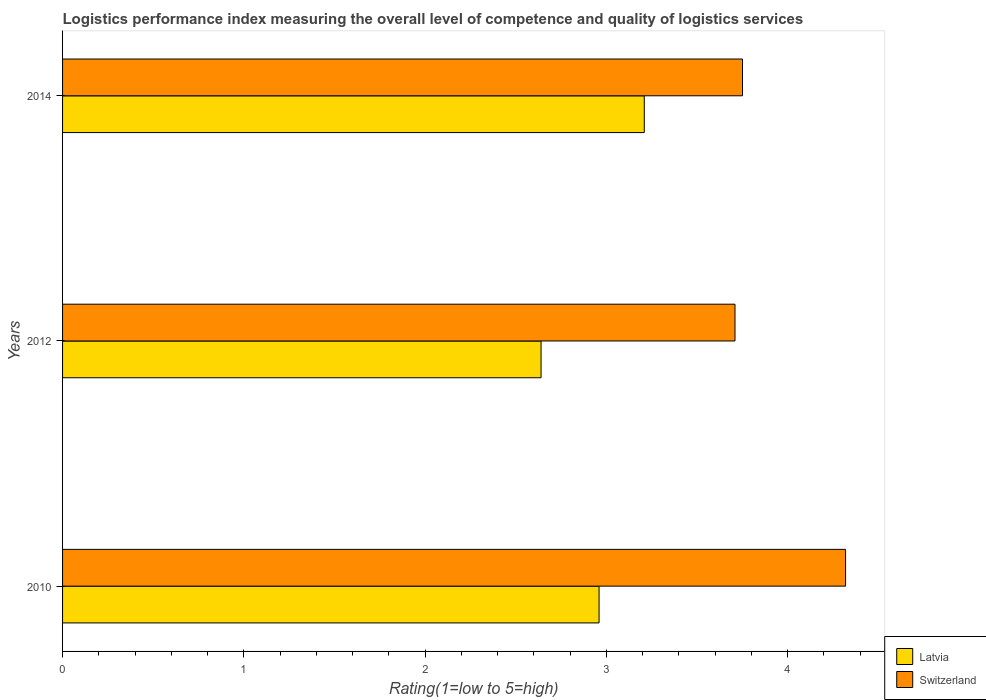How many groups of bars are there?
Offer a terse response. 3. How many bars are there on the 3rd tick from the top?
Offer a terse response. 2. How many bars are there on the 3rd tick from the bottom?
Make the answer very short. 2. In how many cases, is the number of bars for a given year not equal to the number of legend labels?
Your answer should be very brief. 0. What is the Logistic performance index in Latvia in 2012?
Offer a terse response. 2.64. Across all years, what is the maximum Logistic performance index in Switzerland?
Provide a short and direct response. 4.32. Across all years, what is the minimum Logistic performance index in Latvia?
Make the answer very short. 2.64. What is the total Logistic performance index in Switzerland in the graph?
Ensure brevity in your answer.  11.78. What is the difference between the Logistic performance index in Switzerland in 2010 and that in 2014?
Your answer should be very brief. 0.57. What is the difference between the Logistic performance index in Latvia in 2010 and the Logistic performance index in Switzerland in 2012?
Offer a very short reply. -0.75. What is the average Logistic performance index in Latvia per year?
Provide a short and direct response. 2.94. In the year 2014, what is the difference between the Logistic performance index in Latvia and Logistic performance index in Switzerland?
Keep it short and to the point. -0.54. In how many years, is the Logistic performance index in Switzerland greater than 1.4 ?
Ensure brevity in your answer.  3. What is the ratio of the Logistic performance index in Latvia in 2010 to that in 2012?
Provide a succinct answer. 1.12. Is the difference between the Logistic performance index in Latvia in 2010 and 2012 greater than the difference between the Logistic performance index in Switzerland in 2010 and 2012?
Provide a succinct answer. No. What is the difference between the highest and the second highest Logistic performance index in Switzerland?
Your answer should be compact. 0.57. What is the difference between the highest and the lowest Logistic performance index in Switzerland?
Provide a succinct answer. 0.61. In how many years, is the Logistic performance index in Switzerland greater than the average Logistic performance index in Switzerland taken over all years?
Ensure brevity in your answer.  1. Is the sum of the Logistic performance index in Switzerland in 2010 and 2012 greater than the maximum Logistic performance index in Latvia across all years?
Keep it short and to the point. Yes. What does the 1st bar from the top in 2012 represents?
Offer a terse response. Switzerland. What does the 1st bar from the bottom in 2014 represents?
Provide a succinct answer. Latvia. How many bars are there?
Offer a very short reply. 6. Does the graph contain any zero values?
Ensure brevity in your answer.  No. How are the legend labels stacked?
Make the answer very short. Vertical. What is the title of the graph?
Keep it short and to the point. Logistics performance index measuring the overall level of competence and quality of logistics services. Does "Montenegro" appear as one of the legend labels in the graph?
Provide a short and direct response. No. What is the label or title of the X-axis?
Offer a very short reply. Rating(1=low to 5=high). What is the label or title of the Y-axis?
Provide a succinct answer. Years. What is the Rating(1=low to 5=high) in Latvia in 2010?
Offer a terse response. 2.96. What is the Rating(1=low to 5=high) of Switzerland in 2010?
Keep it short and to the point. 4.32. What is the Rating(1=low to 5=high) of Latvia in 2012?
Make the answer very short. 2.64. What is the Rating(1=low to 5=high) of Switzerland in 2012?
Provide a short and direct response. 3.71. What is the Rating(1=low to 5=high) in Latvia in 2014?
Your response must be concise. 3.21. What is the Rating(1=low to 5=high) in Switzerland in 2014?
Offer a terse response. 3.75. Across all years, what is the maximum Rating(1=low to 5=high) in Latvia?
Your answer should be very brief. 3.21. Across all years, what is the maximum Rating(1=low to 5=high) of Switzerland?
Your response must be concise. 4.32. Across all years, what is the minimum Rating(1=low to 5=high) in Latvia?
Keep it short and to the point. 2.64. Across all years, what is the minimum Rating(1=low to 5=high) of Switzerland?
Ensure brevity in your answer.  3.71. What is the total Rating(1=low to 5=high) of Latvia in the graph?
Offer a terse response. 8.81. What is the total Rating(1=low to 5=high) in Switzerland in the graph?
Give a very brief answer. 11.78. What is the difference between the Rating(1=low to 5=high) of Latvia in 2010 and that in 2012?
Provide a succinct answer. 0.32. What is the difference between the Rating(1=low to 5=high) in Switzerland in 2010 and that in 2012?
Provide a short and direct response. 0.61. What is the difference between the Rating(1=low to 5=high) in Latvia in 2010 and that in 2014?
Offer a very short reply. -0.25. What is the difference between the Rating(1=low to 5=high) in Switzerland in 2010 and that in 2014?
Your answer should be very brief. 0.57. What is the difference between the Rating(1=low to 5=high) in Latvia in 2012 and that in 2014?
Keep it short and to the point. -0.57. What is the difference between the Rating(1=low to 5=high) in Switzerland in 2012 and that in 2014?
Provide a succinct answer. -0.04. What is the difference between the Rating(1=low to 5=high) in Latvia in 2010 and the Rating(1=low to 5=high) in Switzerland in 2012?
Offer a very short reply. -0.75. What is the difference between the Rating(1=low to 5=high) in Latvia in 2010 and the Rating(1=low to 5=high) in Switzerland in 2014?
Ensure brevity in your answer.  -0.79. What is the difference between the Rating(1=low to 5=high) of Latvia in 2012 and the Rating(1=low to 5=high) of Switzerland in 2014?
Ensure brevity in your answer.  -1.11. What is the average Rating(1=low to 5=high) of Latvia per year?
Offer a very short reply. 2.94. What is the average Rating(1=low to 5=high) of Switzerland per year?
Offer a very short reply. 3.93. In the year 2010, what is the difference between the Rating(1=low to 5=high) in Latvia and Rating(1=low to 5=high) in Switzerland?
Your answer should be very brief. -1.36. In the year 2012, what is the difference between the Rating(1=low to 5=high) of Latvia and Rating(1=low to 5=high) of Switzerland?
Offer a terse response. -1.07. In the year 2014, what is the difference between the Rating(1=low to 5=high) of Latvia and Rating(1=low to 5=high) of Switzerland?
Make the answer very short. -0.54. What is the ratio of the Rating(1=low to 5=high) in Latvia in 2010 to that in 2012?
Offer a very short reply. 1.12. What is the ratio of the Rating(1=low to 5=high) of Switzerland in 2010 to that in 2012?
Your response must be concise. 1.16. What is the ratio of the Rating(1=low to 5=high) in Latvia in 2010 to that in 2014?
Your answer should be very brief. 0.92. What is the ratio of the Rating(1=low to 5=high) of Switzerland in 2010 to that in 2014?
Make the answer very short. 1.15. What is the ratio of the Rating(1=low to 5=high) of Latvia in 2012 to that in 2014?
Give a very brief answer. 0.82. What is the ratio of the Rating(1=low to 5=high) of Switzerland in 2012 to that in 2014?
Your answer should be very brief. 0.99. What is the difference between the highest and the second highest Rating(1=low to 5=high) in Latvia?
Ensure brevity in your answer.  0.25. What is the difference between the highest and the second highest Rating(1=low to 5=high) of Switzerland?
Offer a very short reply. 0.57. What is the difference between the highest and the lowest Rating(1=low to 5=high) in Latvia?
Keep it short and to the point. 0.57. What is the difference between the highest and the lowest Rating(1=low to 5=high) of Switzerland?
Your answer should be very brief. 0.61. 